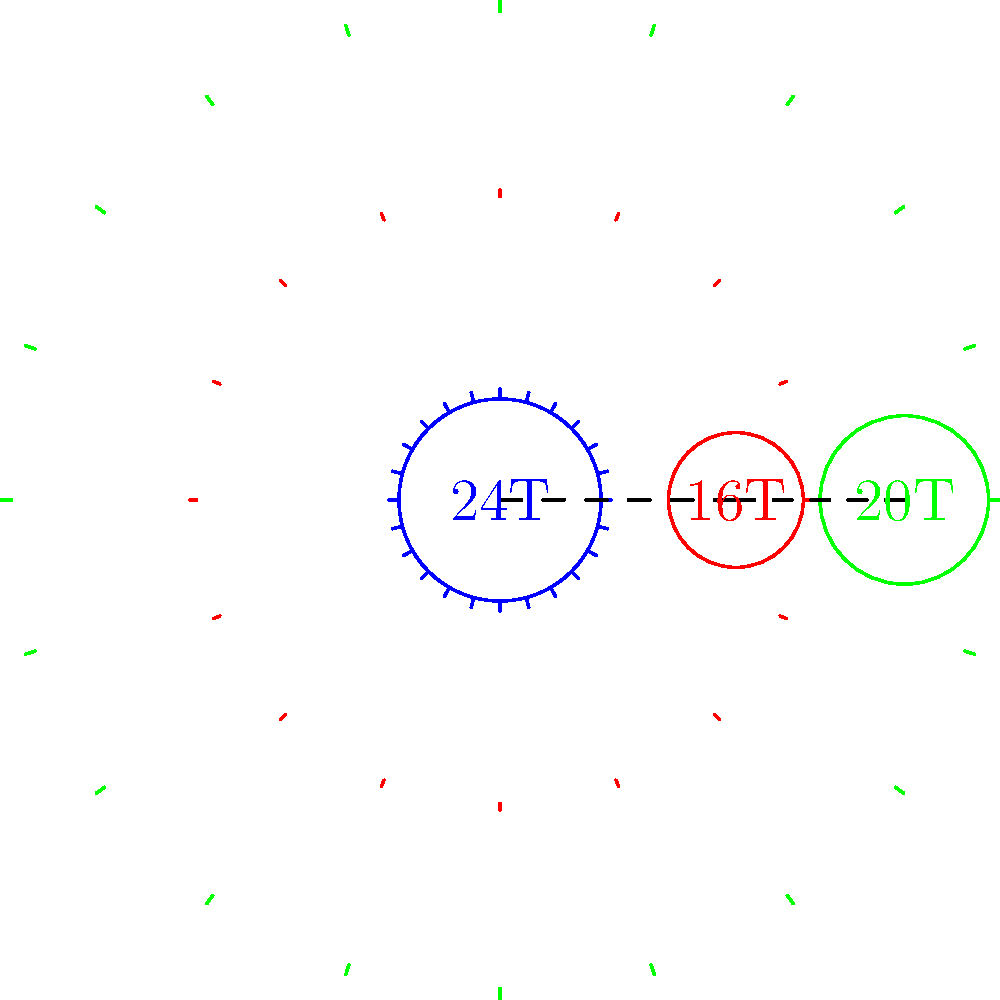A gear train consists of three gears with 24, 16, and 20 teeth, respectively, as shown in the figure. If the input gear (24T) rotates at 1200 RPM and the efficiency of each gear mesh is 98%, calculate the output speed of the final gear (20T) and the overall efficiency of the gear train. To solve this problem, we'll follow these steps:

1. Calculate the gear ratios:
   First gear ratio: $GR_1 = \frac{N_2}{N_1} = \frac{16}{24} = \frac{2}{3}$
   Second gear ratio: $GR_2 = \frac{N_3}{N_2} = \frac{20}{16} = \frac{5}{4}$

2. Calculate the overall gear ratio:
   $GR_{total} = GR_1 \times GR_2 = \frac{2}{3} \times \frac{5}{4} = \frac{5}{6}$

3. Calculate the output speed:
   $\text{Output Speed} = \text{Input Speed} \times GR_{total}$
   $\text{Output Speed} = 1200 \text{ RPM} \times \frac{5}{6} = 1000 \text{ RPM}$

4. Calculate the overall efficiency:
   Since there are two gear meshes, and each has an efficiency of 98%:
   $\text{Overall Efficiency} = (0.98)^2 = 0.9604 = 96.04\%$
Answer: Output speed: 1000 RPM; Overall efficiency: 96.04% 